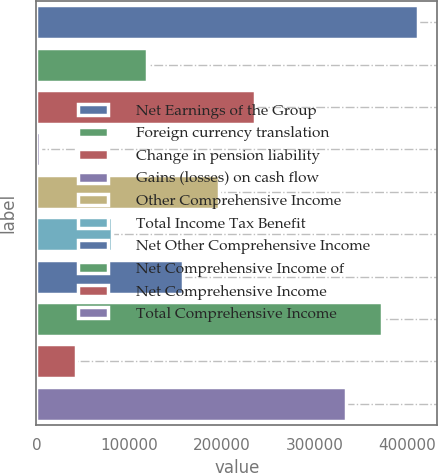Convert chart to OTSL. <chart><loc_0><loc_0><loc_500><loc_500><bar_chart><fcel>Net Earnings of the Group<fcel>Foreign currency translation<fcel>Change in pension liability<fcel>Gains (losses) on cash flow<fcel>Other Comprehensive Income<fcel>Total Income Tax Benefit<fcel>Net Other Comprehensive Income<fcel>Net Comprehensive Income of<fcel>Net Comprehensive Income<fcel>Total Comprehensive Income<nl><fcel>412082<fcel>119783<fcel>235999<fcel>3567<fcel>197260<fcel>81044.4<fcel>158522<fcel>373344<fcel>42305.7<fcel>334605<nl></chart> 